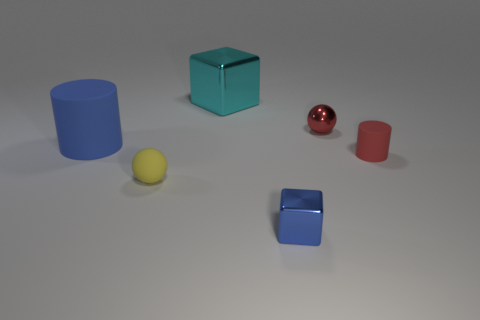Add 1 rubber objects. How many objects exist? 7 Subtract all spheres. How many objects are left? 4 Add 6 big blue rubber cylinders. How many big blue rubber cylinders are left? 7 Add 2 small red metallic balls. How many small red metallic balls exist? 3 Subtract 0 gray spheres. How many objects are left? 6 Subtract 2 spheres. How many spheres are left? 0 Subtract all green spheres. Subtract all brown blocks. How many spheres are left? 2 Subtract all brown cylinders. How many purple cubes are left? 0 Subtract all balls. Subtract all metallic spheres. How many objects are left? 3 